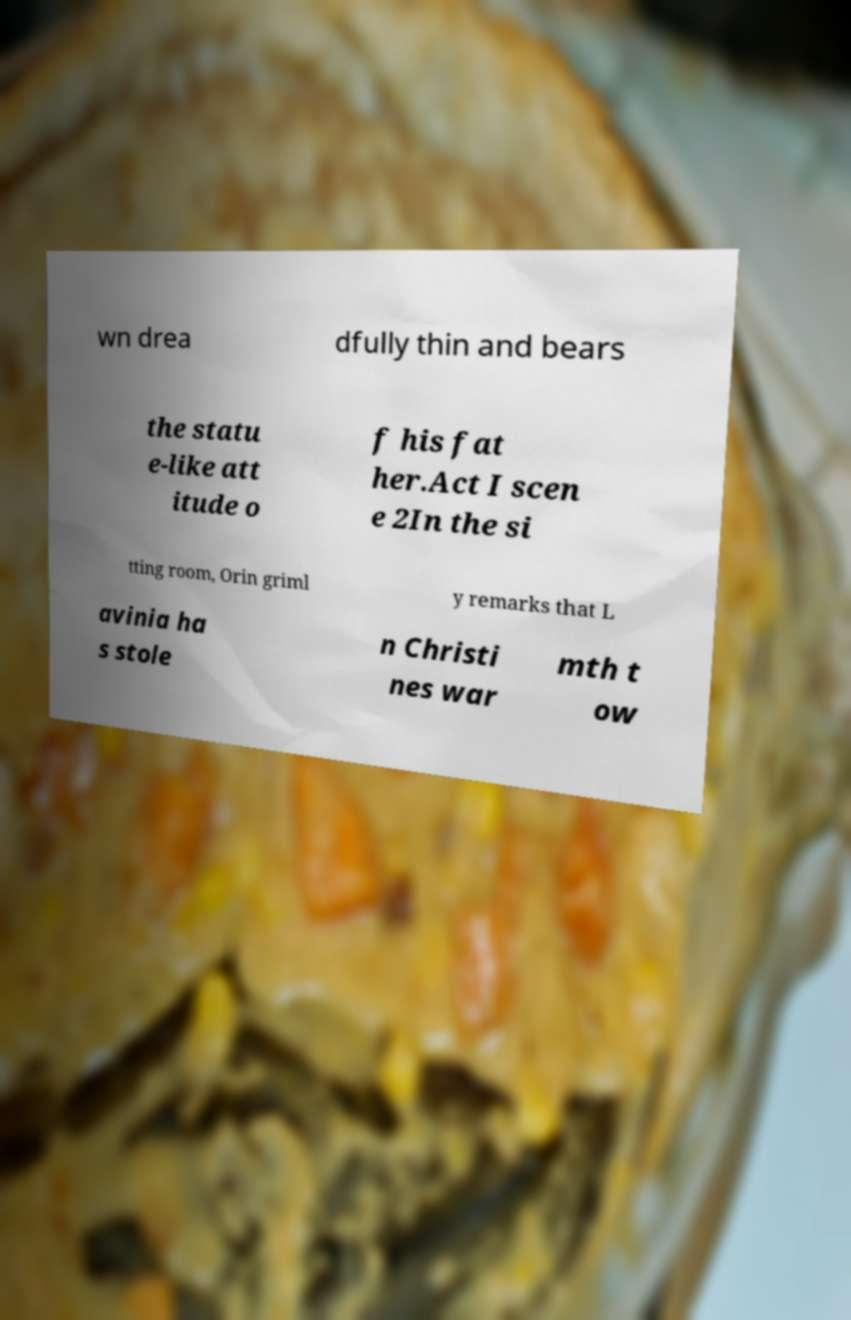I need the written content from this picture converted into text. Can you do that? wn drea dfully thin and bears the statu e-like att itude o f his fat her.Act I scen e 2In the si tting room, Orin griml y remarks that L avinia ha s stole n Christi nes war mth t ow 